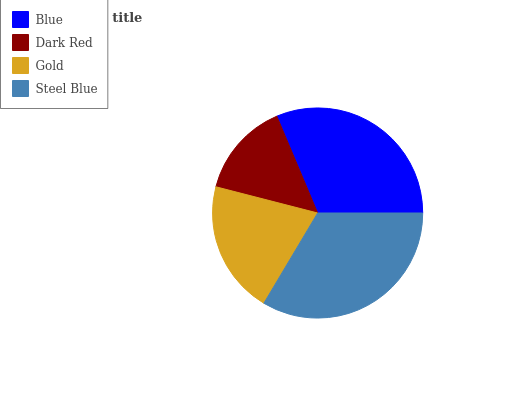Is Dark Red the minimum?
Answer yes or no. Yes. Is Steel Blue the maximum?
Answer yes or no. Yes. Is Gold the minimum?
Answer yes or no. No. Is Gold the maximum?
Answer yes or no. No. Is Gold greater than Dark Red?
Answer yes or no. Yes. Is Dark Red less than Gold?
Answer yes or no. Yes. Is Dark Red greater than Gold?
Answer yes or no. No. Is Gold less than Dark Red?
Answer yes or no. No. Is Blue the high median?
Answer yes or no. Yes. Is Gold the low median?
Answer yes or no. Yes. Is Dark Red the high median?
Answer yes or no. No. Is Blue the low median?
Answer yes or no. No. 